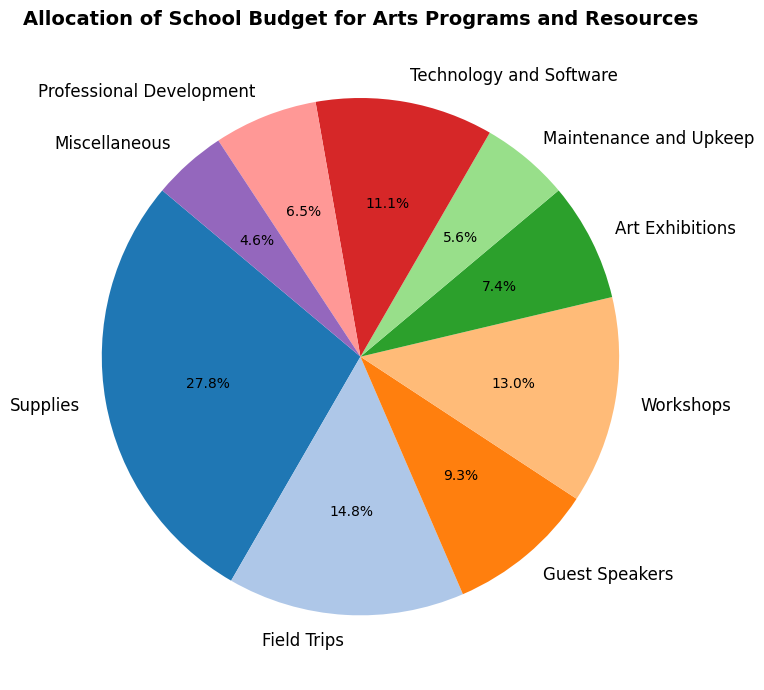What category receives the largest portion of the budget? By examining the slices in the pie chart, you can identify the segment with the largest percentage. This corresponds to the category labeled "Supplies."
Answer: Supplies Which category receives the lowest allocation in the budget? The smallest slice in the pie chart represents the category with the lowest budget allocation, which in this case is "Miscellaneous."
Answer: Miscellaneous What is the combined allocation for Field Trips and Guest Speakers? To find the combined allocation, you sum the amounts allocated to Field Trips (8000) and Guest Speakers (5000). This results in a total allocation of 8000 + 5000 = 13000.
Answer: 13000 How much more is allocated to Supplies compared to Technology and Software? The allocation for Supplies is 15000, and for Technology and Software, it is 6000. The difference between the two is 15000 - 6000 = 9000.
Answer: 9000 Which category's allocation is closest in size to Workshops? To find the closest allocation to Workshops (7000), compare the amounts of other categories. Field Trips have an allocation of 8000, which is closest to 7000.
Answer: Field Trips What two categories combined make up a similar percentage of the budget as Supplies alone? Supplies alone is 15000. Combine other categories to match or come close to this amount. Field Trips (8000) and Guest Speakers (5000) together make 13000, and with Maintenance and Upkeep (3000), the total is 16000, which is the closest match.
Answer: Field Trips and Guest Speakers What percentage of the total budget is allocated to Professional Development? The total budget sum is 54000. Professional Development's allocation is 3500. The percentage is calculated as (3500 / 54000) * 100 ≈ 6.48%.
Answer: 6.48% How does the allocation for Art Exhibitions compare to Maintenance and Upkeep? By comparing the slices in the pie chart, you see the segment sizes. Art Exhibitions (4000) receive more than Maintenance and Upkeep (3000).
Answer: Art Exhibitions What is the sum of allocations for categories that are below 5000? The categories below 5000 are Guest Speakers (5000), Art Exhibitions (4000), Maintenance and Upkeep (3000), Professional Development (3500), and Miscellaneous (2500). Summing these amounts gives 5000 + 4000 + 3000 + 3500 + 2500 = 18000.
Answer: 18000 